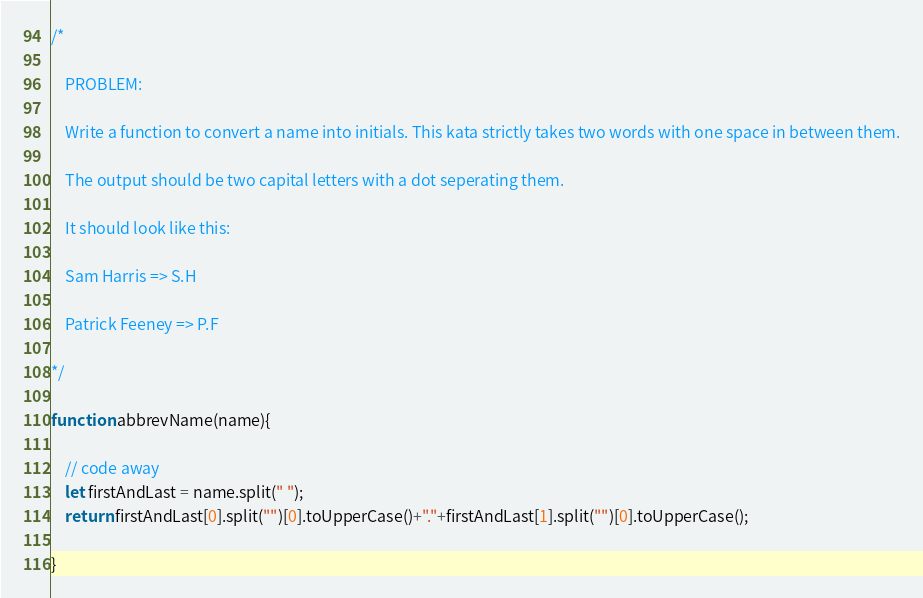<code> <loc_0><loc_0><loc_500><loc_500><_JavaScript_>/*

    PROBLEM:

    Write a function to convert a name into initials. This kata strictly takes two words with one space in between them.

    The output should be two capital letters with a dot seperating them.

    It should look like this:

    Sam Harris => S.H

    Patrick Feeney => P.F

*/

function abbrevName(name){

    // code away
    let firstAndLast = name.split(" ");
    return firstAndLast[0].split("")[0].toUpperCase()+"."+firstAndLast[1].split("")[0].toUpperCase();

}
</code> 